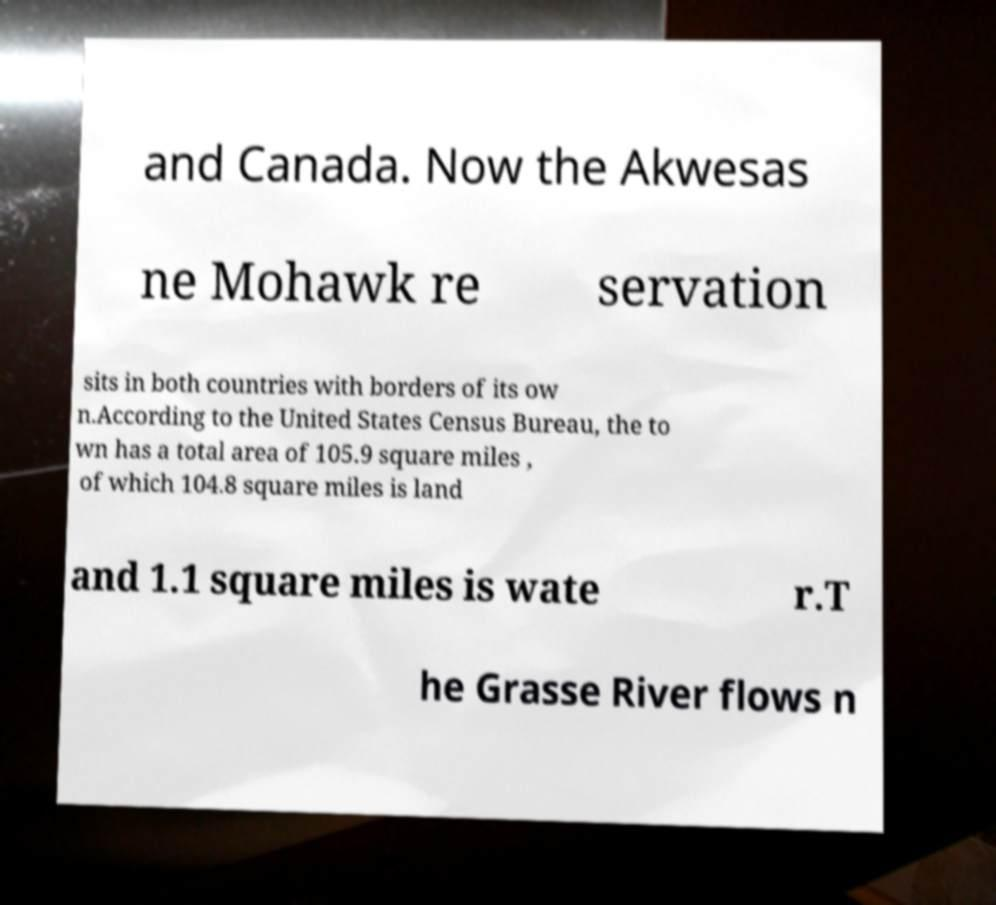Can you accurately transcribe the text from the provided image for me? and Canada. Now the Akwesas ne Mohawk re servation sits in both countries with borders of its ow n.According to the United States Census Bureau, the to wn has a total area of 105.9 square miles , of which 104.8 square miles is land and 1.1 square miles is wate r.T he Grasse River flows n 